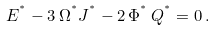Convert formula to latex. <formula><loc_0><loc_0><loc_500><loc_500>E ^ { ^ { * } } - 3 \, \Omega ^ { ^ { * } } J ^ { ^ { * } } - 2 \, \Phi ^ { ^ { * } } \, Q ^ { ^ { * } } = 0 \, .</formula> 